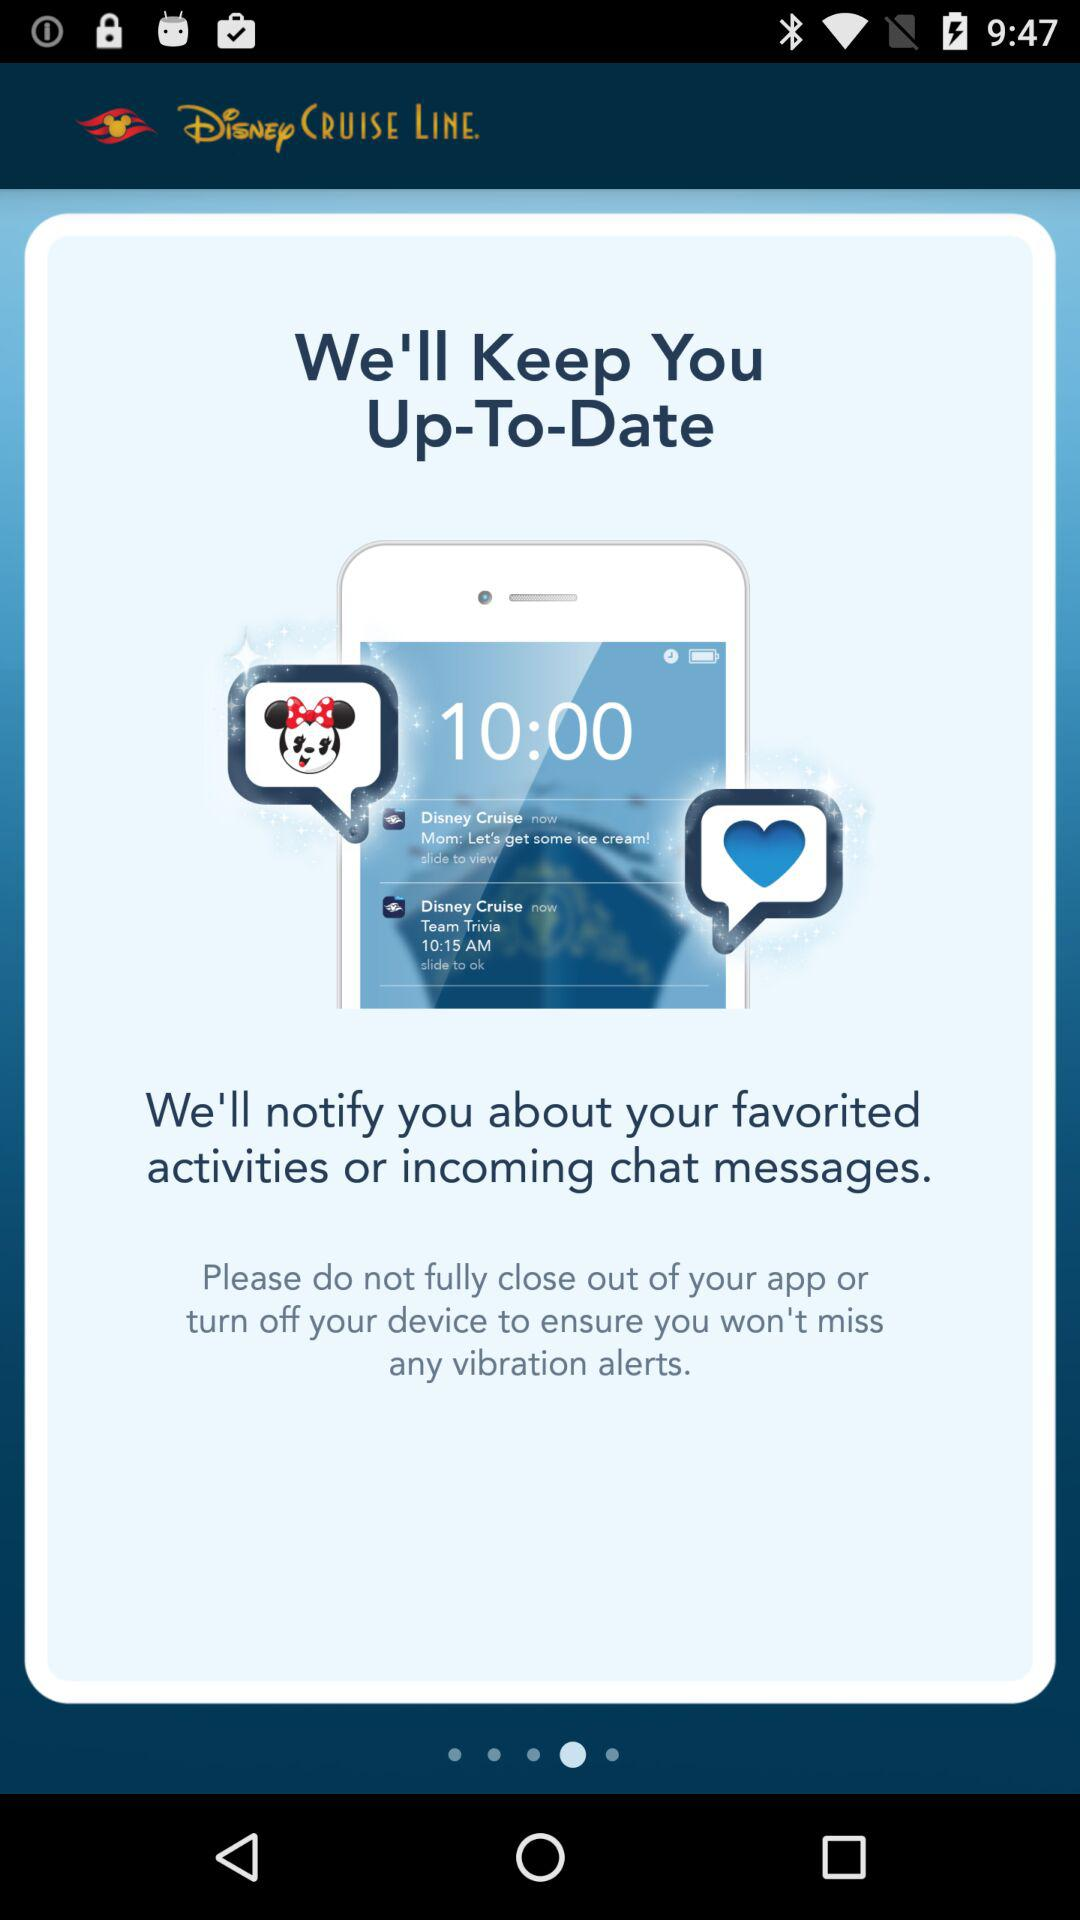Who is this application powered by?
When the provided information is insufficient, respond with <no answer>. <no answer> 